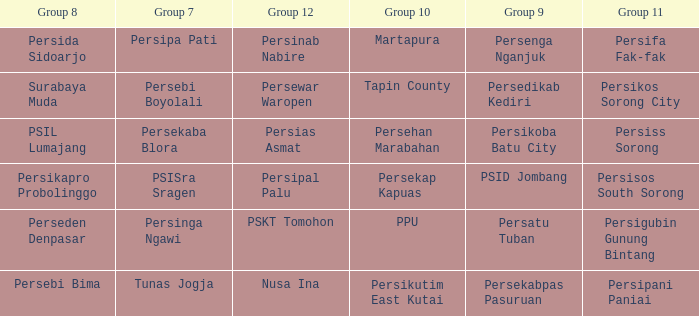Who played in group 11 when Persipal Palu played in group 12? Persisos South Sorong. 